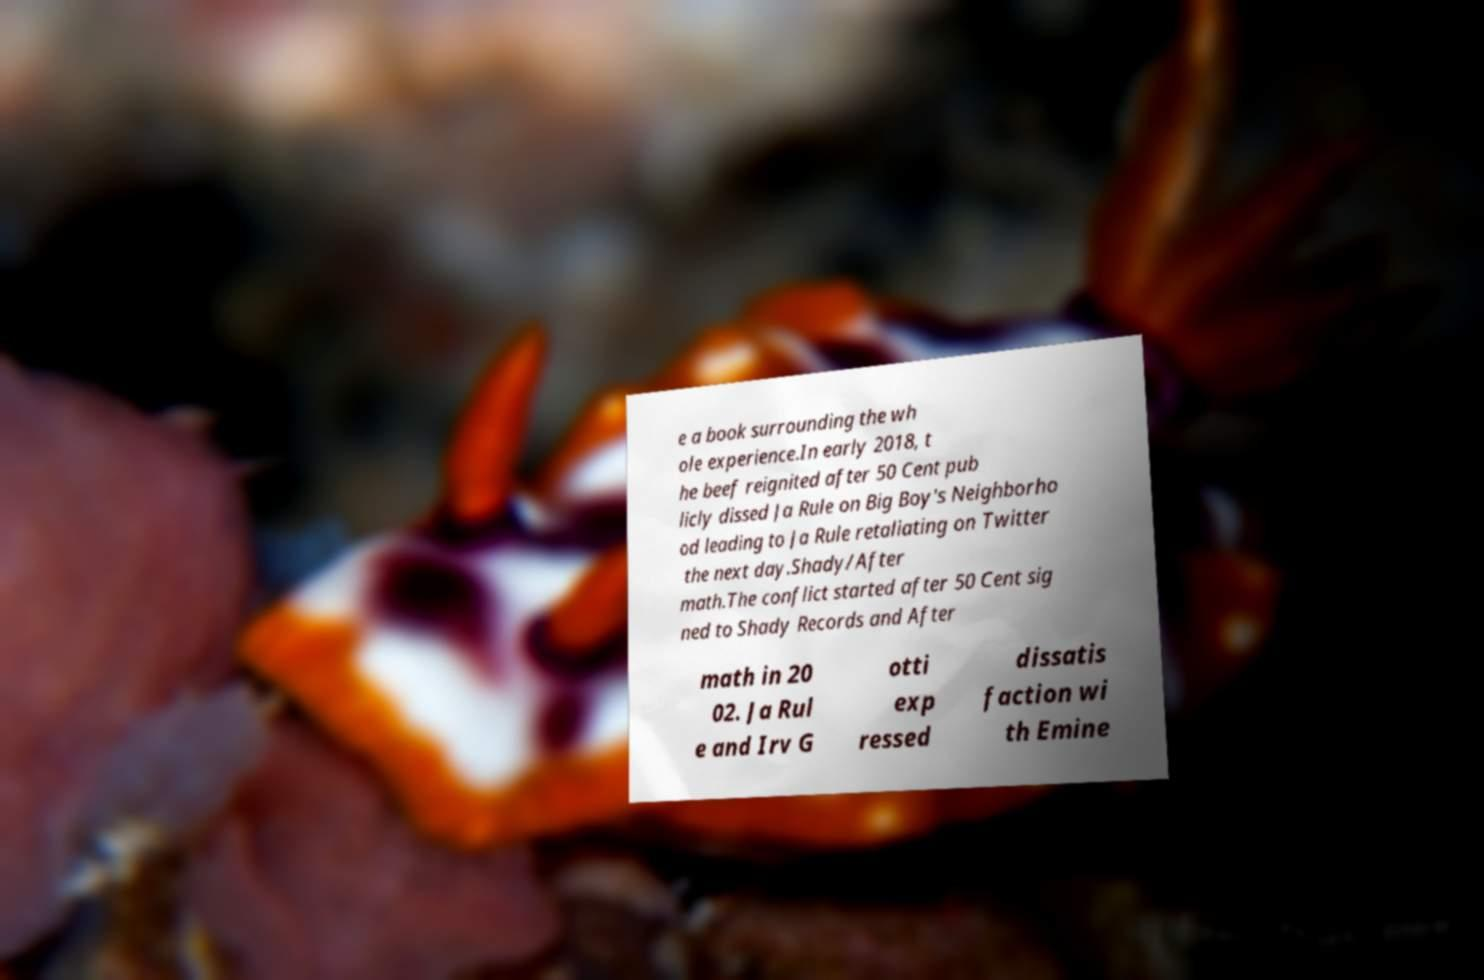For documentation purposes, I need the text within this image transcribed. Could you provide that? e a book surrounding the wh ole experience.In early 2018, t he beef reignited after 50 Cent pub licly dissed Ja Rule on Big Boy's Neighborho od leading to Ja Rule retaliating on Twitter the next day.Shady/After math.The conflict started after 50 Cent sig ned to Shady Records and After math in 20 02. Ja Rul e and Irv G otti exp ressed dissatis faction wi th Emine 